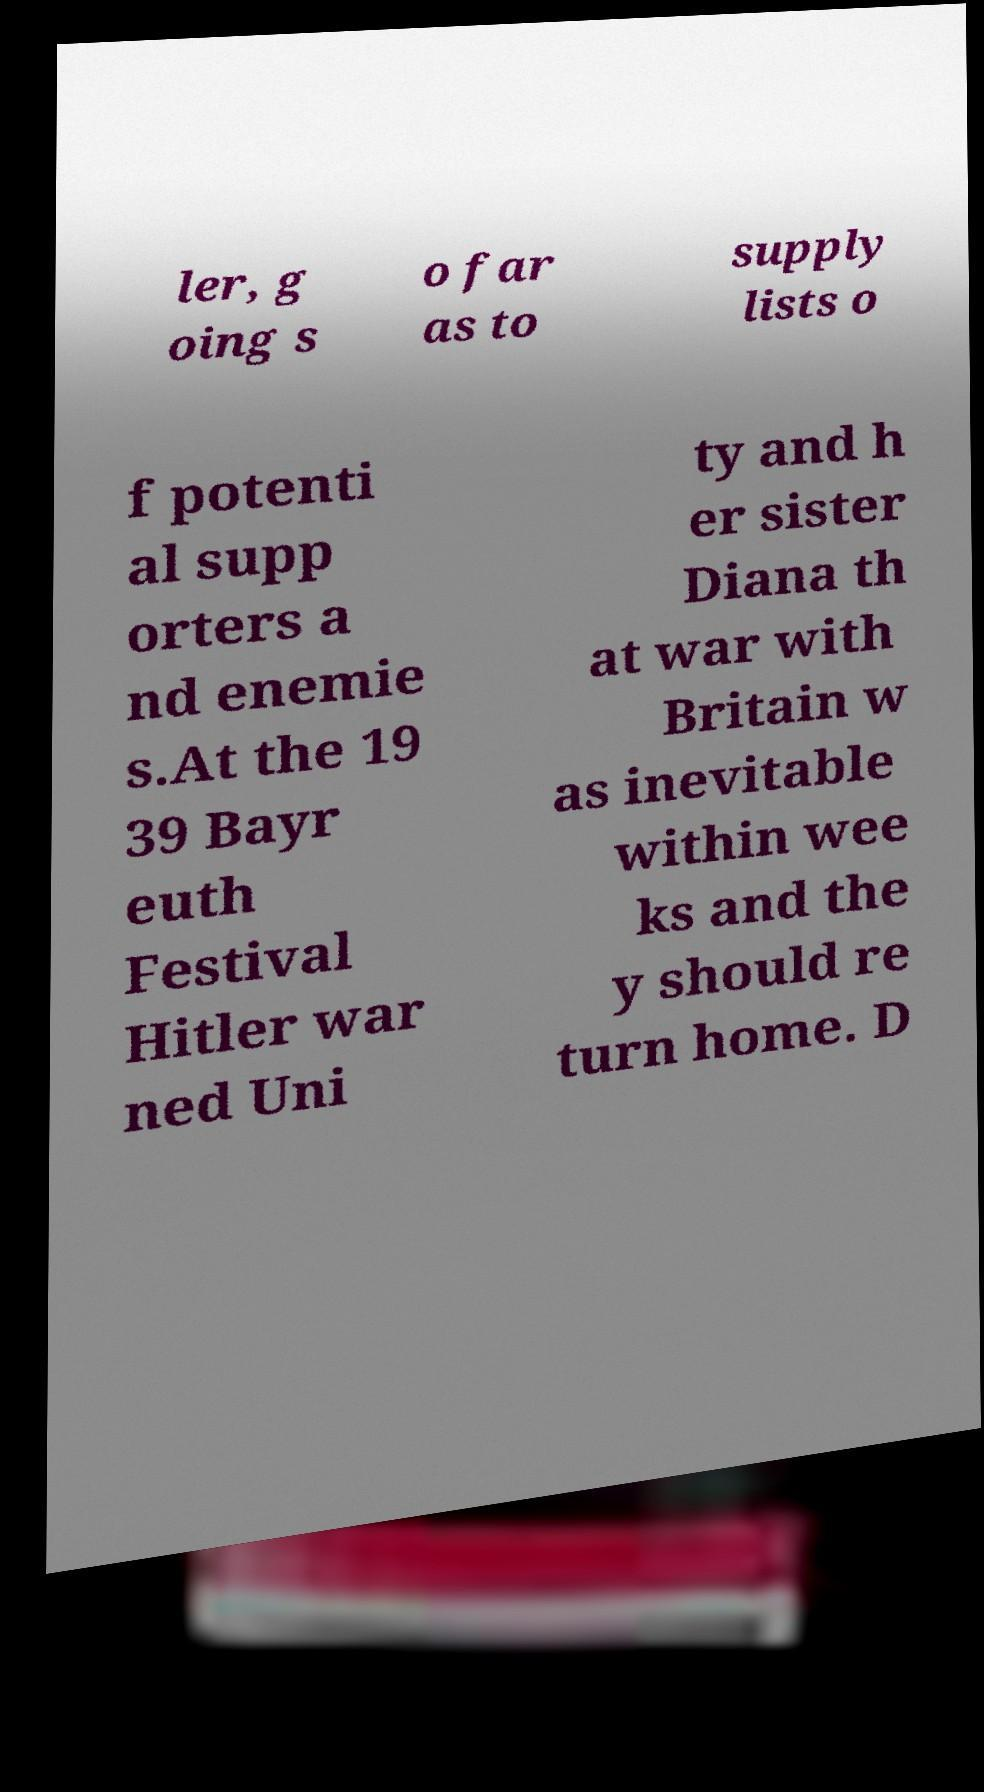There's text embedded in this image that I need extracted. Can you transcribe it verbatim? ler, g oing s o far as to supply lists o f potenti al supp orters a nd enemie s.At the 19 39 Bayr euth Festival Hitler war ned Uni ty and h er sister Diana th at war with Britain w as inevitable within wee ks and the y should re turn home. D 